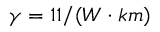Convert formula to latex. <formula><loc_0><loc_0><loc_500><loc_500>\gamma = 1 1 / ( W \cdot k m )</formula> 